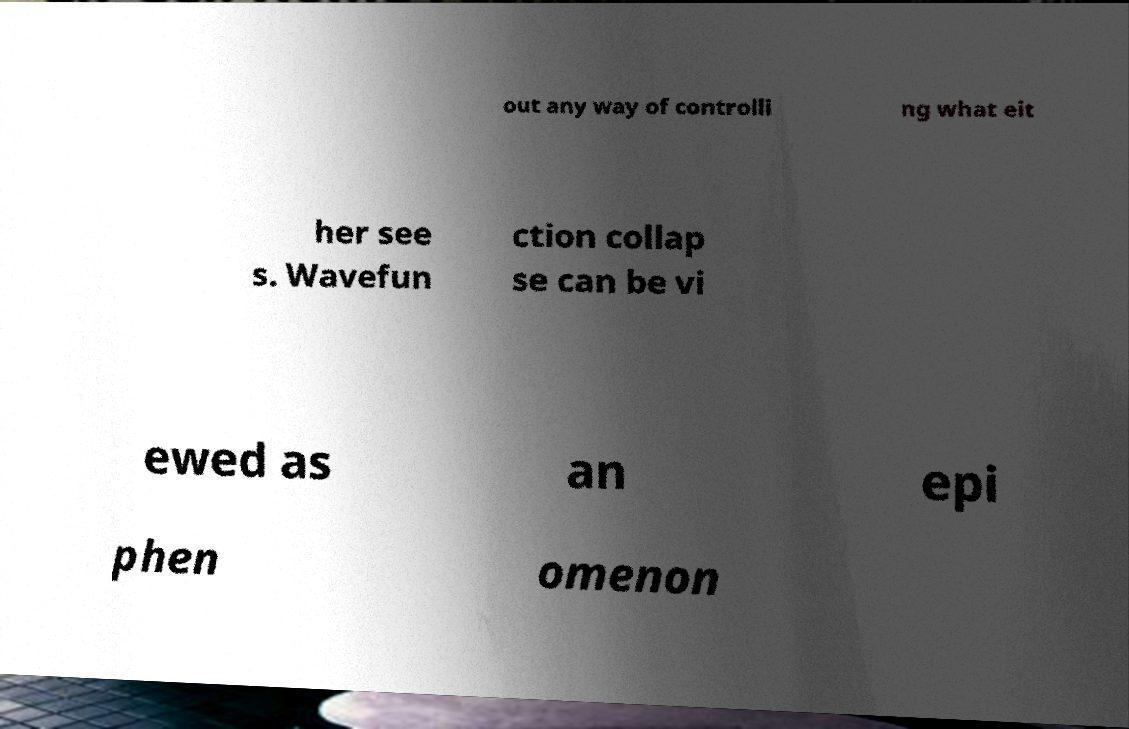For documentation purposes, I need the text within this image transcribed. Could you provide that? out any way of controlli ng what eit her see s. Wavefun ction collap se can be vi ewed as an epi phen omenon 